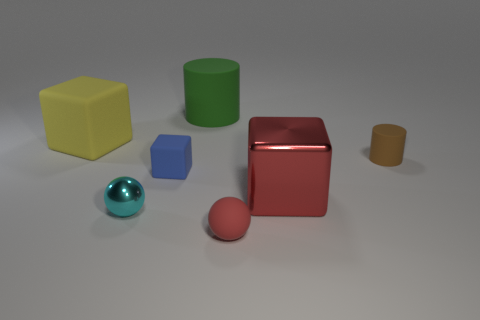Add 3 yellow things. How many objects exist? 10 Subtract all spheres. How many objects are left? 5 Subtract all small red matte cubes. Subtract all cyan spheres. How many objects are left? 6 Add 1 large green matte things. How many large green matte things are left? 2 Add 6 rubber cubes. How many rubber cubes exist? 8 Subtract 0 yellow spheres. How many objects are left? 7 